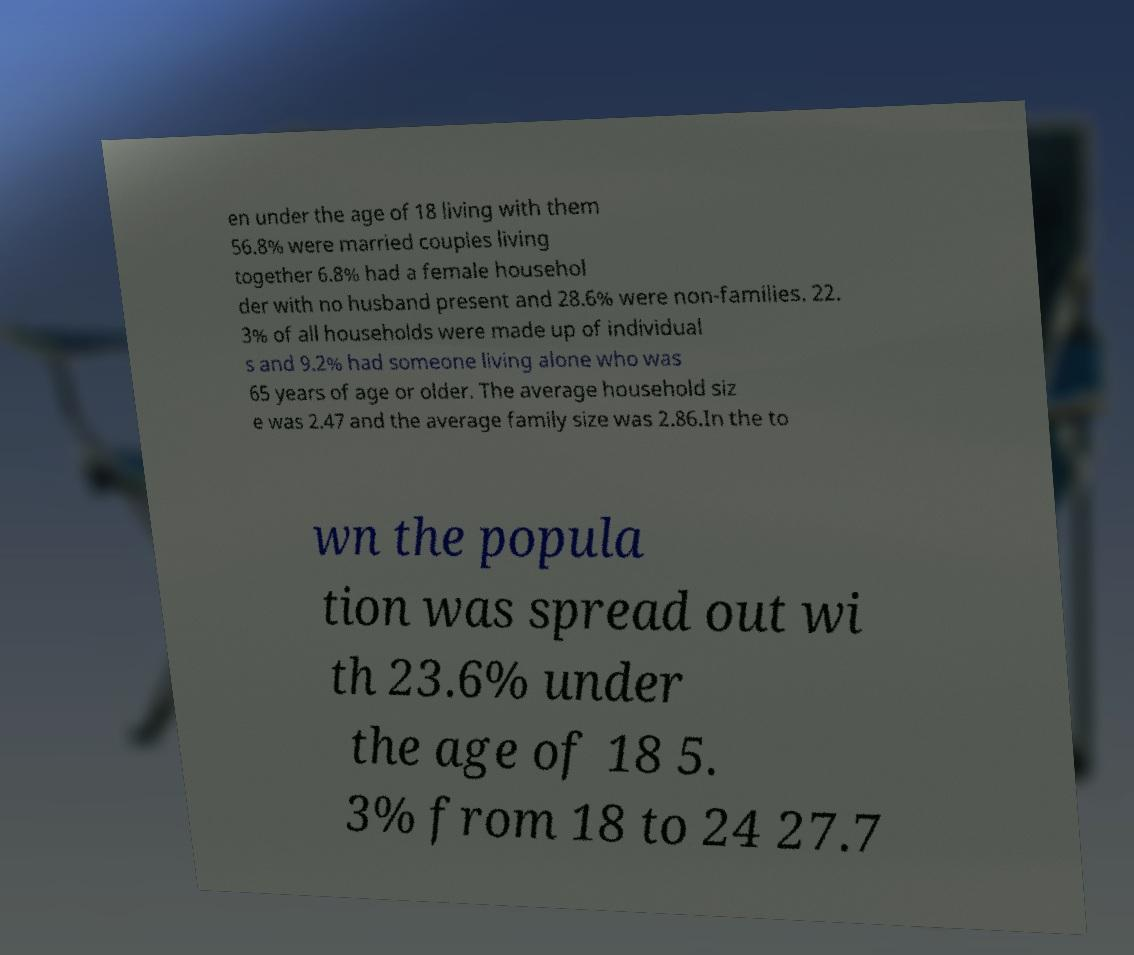Can you accurately transcribe the text from the provided image for me? en under the age of 18 living with them 56.8% were married couples living together 6.8% had a female househol der with no husband present and 28.6% were non-families. 22. 3% of all households were made up of individual s and 9.2% had someone living alone who was 65 years of age or older. The average household siz e was 2.47 and the average family size was 2.86.In the to wn the popula tion was spread out wi th 23.6% under the age of 18 5. 3% from 18 to 24 27.7 